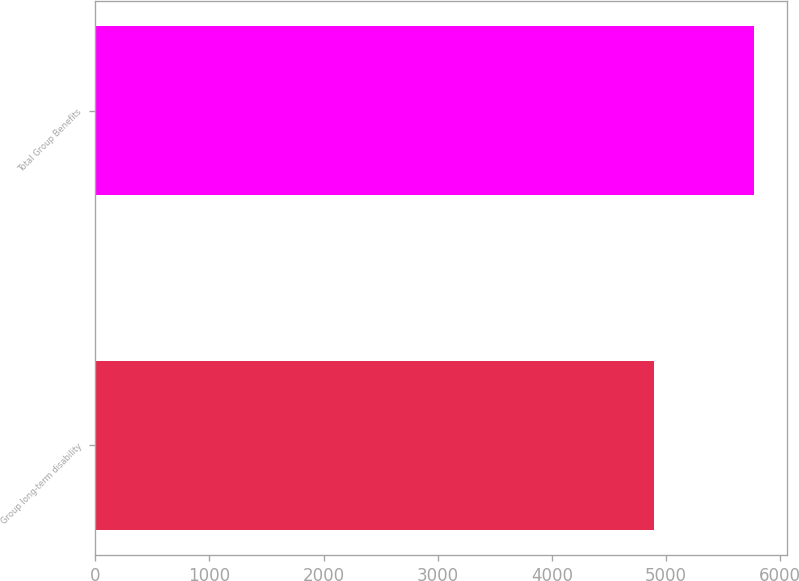Convert chart. <chart><loc_0><loc_0><loc_500><loc_500><bar_chart><fcel>Group long-term disability<fcel>Total Group Benefits<nl><fcel>4893<fcel>5772<nl></chart> 